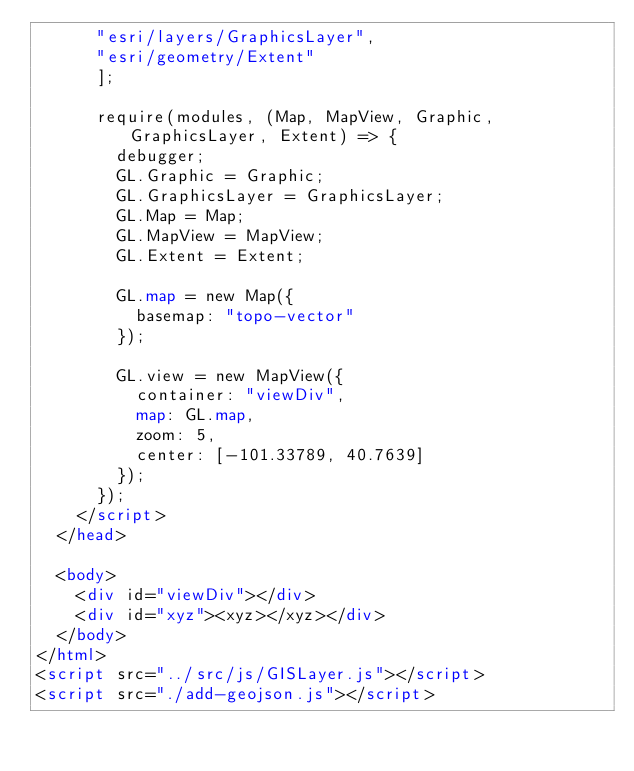Convert code to text. <code><loc_0><loc_0><loc_500><loc_500><_HTML_>      "esri/layers/GraphicsLayer",
      "esri/geometry/Extent"
      ];

      require(modules, (Map, MapView, Graphic, GraphicsLayer, Extent) => {
        debugger;
        GL.Graphic = Graphic;
        GL.GraphicsLayer = GraphicsLayer;
        GL.Map = Map;
        GL.MapView = MapView;
        GL.Extent = Extent;

        GL.map = new Map({
          basemap: "topo-vector"
        });

        GL.view = new MapView({
          container: "viewDiv",
          map: GL.map,
          zoom: 5,
          center: [-101.33789, 40.7639]
        });
      });
    </script>
  </head>

  <body>
    <div id="viewDiv"></div>
    <div id="xyz"><xyz></xyz></div>
  </body>
</html>
<script src="../src/js/GISLayer.js"></script>
<script src="./add-geojson.js"></script></code> 